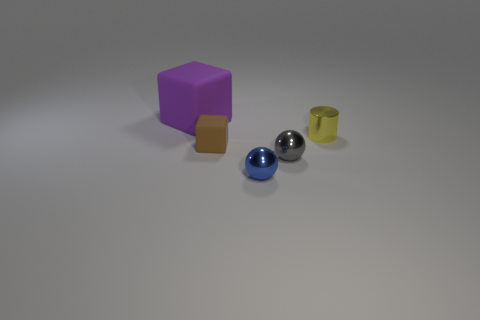Could you describe the lighting and mood of the scene? The scene is evenly lit with what could be considered as soft, diffused lighting, potentially simulating an overcast day or studio lighting. This creates minimal shadows and a calm, neutral mood without strong emotional connotations. 